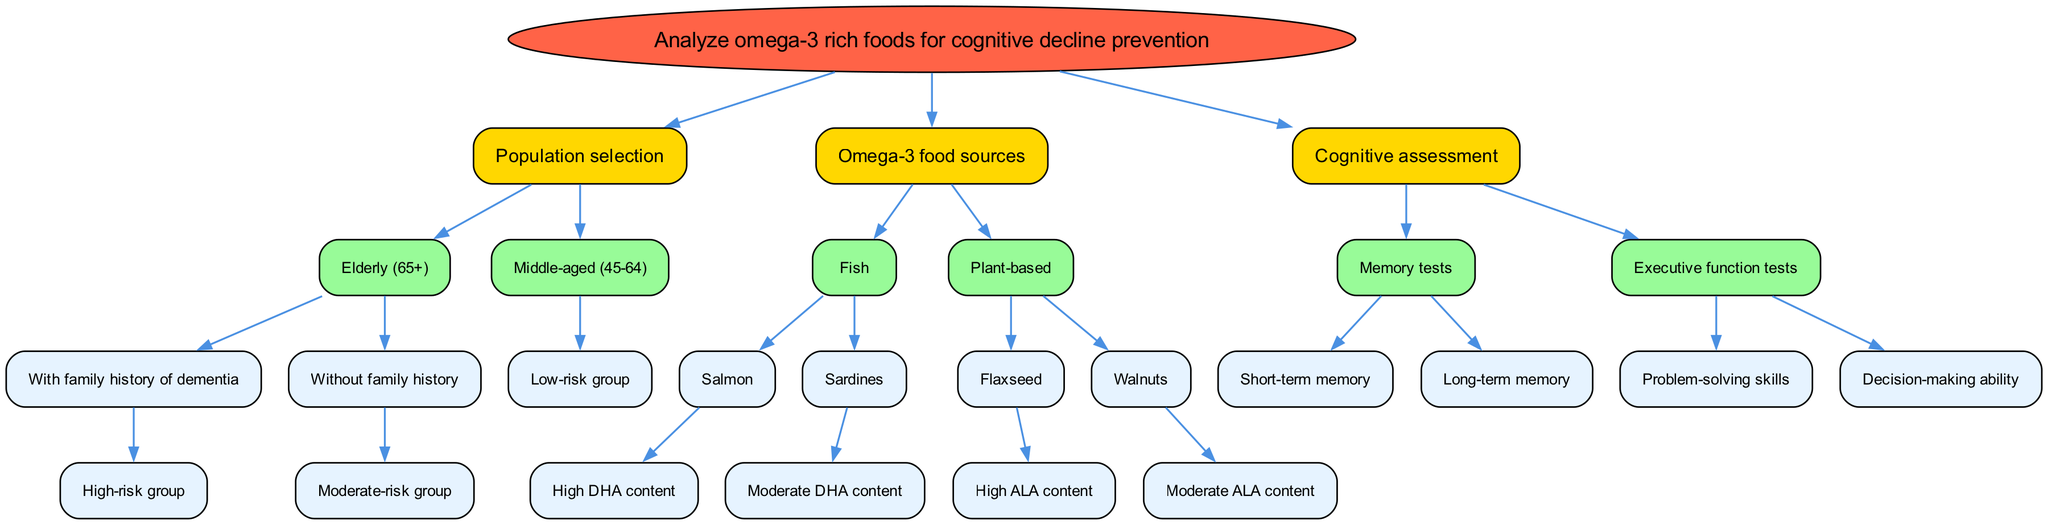What is the root node of the diagram? The root node is the starting point of the decision tree, which outlines the main topic of the analysis. In this case, it is "Analyze omega-3 rich foods for cognitive decline prevention."
Answer: Analyze omega-3 rich foods for cognitive decline prevention How many main branches does the diagram have? There are three main branches stemming from the root node: "Population selection," "Omega-3 food sources," and "Cognitive assessment." This counts as three distinct categories of analysis within the diagram.
Answer: 3 What group is classified as the high-risk group? The high-risk group is defined under the population selection for the "Elderly (65+)" category with a family history of dementia. This classification suggests a focus on those more likely to experience cognitive decline.
Answer: With family history of dementia Which omega-3 food source has high DHA content? The omega-3 food source with high DHA content specified in the diagram is "Salmon." This indicates that this fish is a significant source of the beneficial omega-3 fatty acid DHA.
Answer: Salmon What type of cognitive assessments are mentioned in the diagram? The cognitive assessments identified in the diagram are divided into two categories: "Memory tests," and "Executive function tests." Each category further specifies the types of tests conducted to evaluate cognitive abilities.
Answer: Memory tests and Executive function tests Which plant-based omega-3 food source is indicated to have moderate ALA content? The plant-based omega-3 food source that has moderate ALA content mentioned in the diagram is "Walnuts." This suggests that while they do contain beneficial omega-3s, they may not be as potent as other sources.
Answer: Walnuts In which population category do "Low-risk group" individuals fall? "Low-risk group" individuals are categorized under "Middle-aged (45-64)." This classification indicates that this age group is considered to have a lower risk of cognitive decline as compared to the elderly population.
Answer: Middle-aged (45-64) Which memory test is included for cognitive assessment? The memory tests included for cognitive assessment are "Short-term memory" and "Long-term memory," which indicate specific areas of cognitive evaluation focused on memory function.
Answer: Short-term memory and Long-term memory What is the relationship between "Fish" and "Salmon" in the diagram? The relationship is hierarchical, as "Salmon" is a specific type of fish listed under the broader category of "Fish." This classification details various sources of omega-3 fatty acids.
Answer: Salmon is a type of Fish 